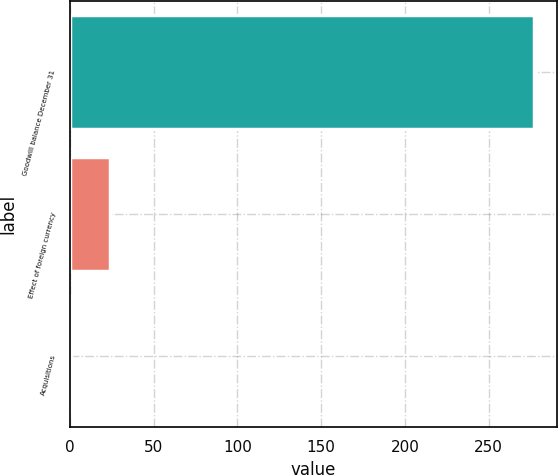Convert chart. <chart><loc_0><loc_0><loc_500><loc_500><bar_chart><fcel>Goodwill balance December 31<fcel>Effect of foreign currency<fcel>Acquisitions<nl><fcel>276.9<fcel>23.93<fcel>0.48<nl></chart> 